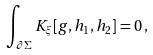Convert formula to latex. <formula><loc_0><loc_0><loc_500><loc_500>\int _ { \partial \Sigma } { K } _ { \xi } [ g , h _ { 1 } , h _ { 2 } ] = 0 \, ,</formula> 